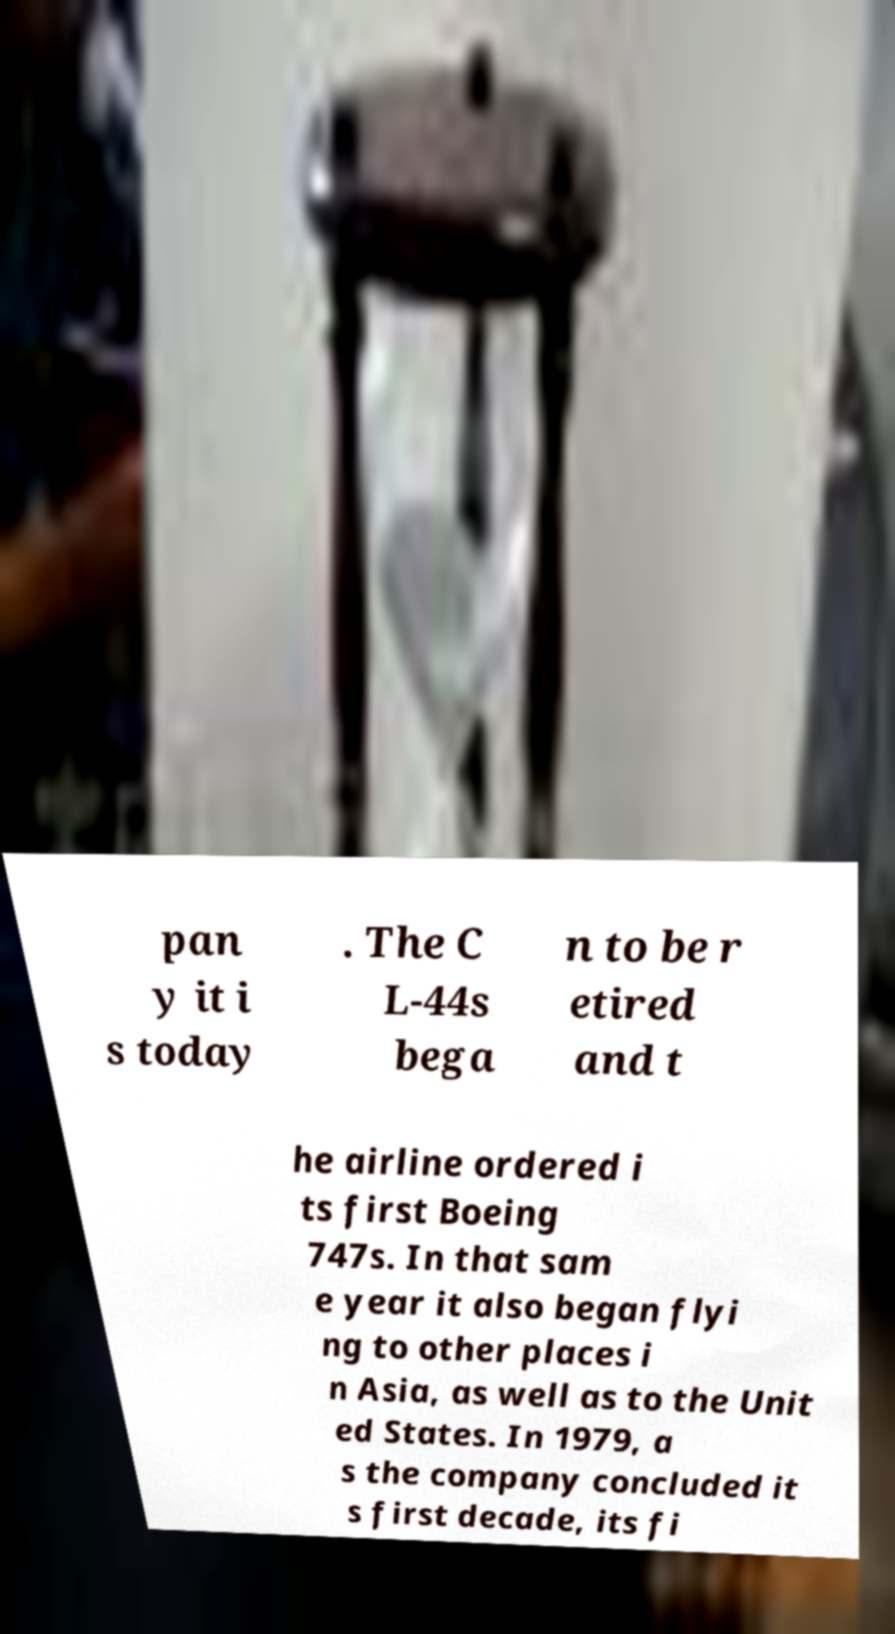Could you extract and type out the text from this image? pan y it i s today . The C L-44s bega n to be r etired and t he airline ordered i ts first Boeing 747s. In that sam e year it also began flyi ng to other places i n Asia, as well as to the Unit ed States. In 1979, a s the company concluded it s first decade, its fi 